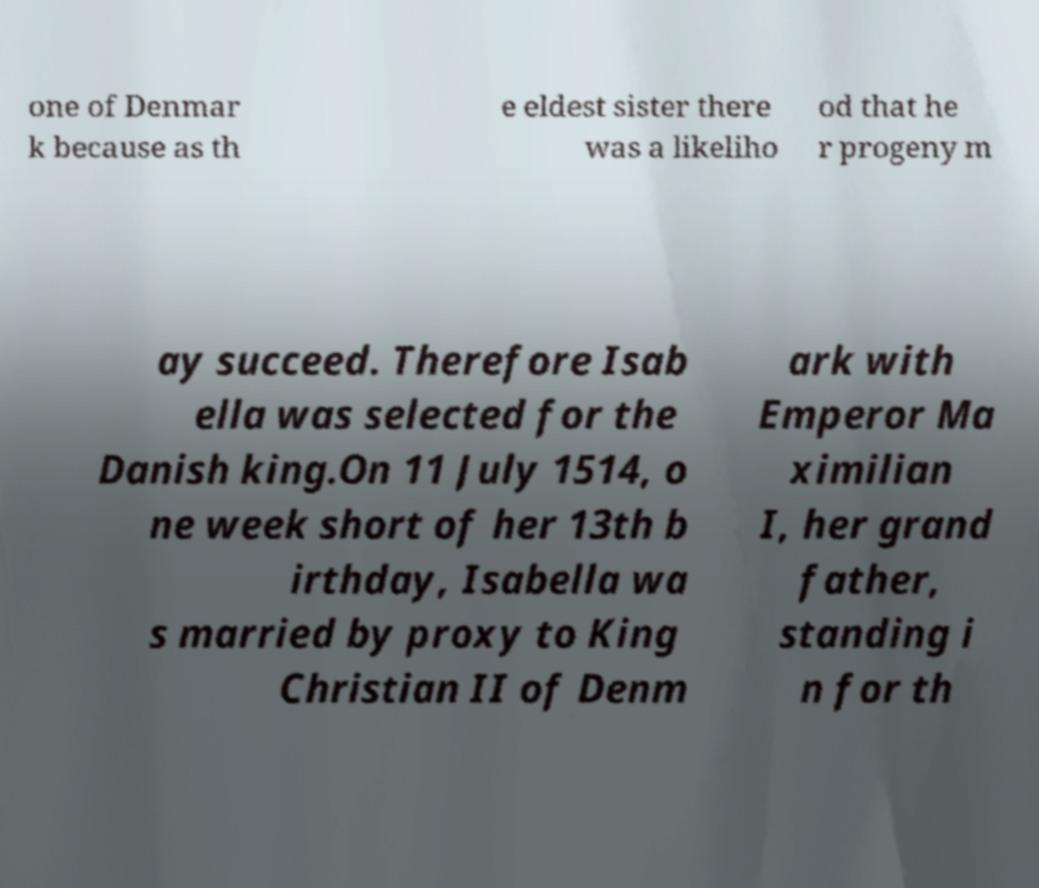There's text embedded in this image that I need extracted. Can you transcribe it verbatim? one of Denmar k because as th e eldest sister there was a likeliho od that he r progeny m ay succeed. Therefore Isab ella was selected for the Danish king.On 11 July 1514, o ne week short of her 13th b irthday, Isabella wa s married by proxy to King Christian II of Denm ark with Emperor Ma ximilian I, her grand father, standing i n for th 